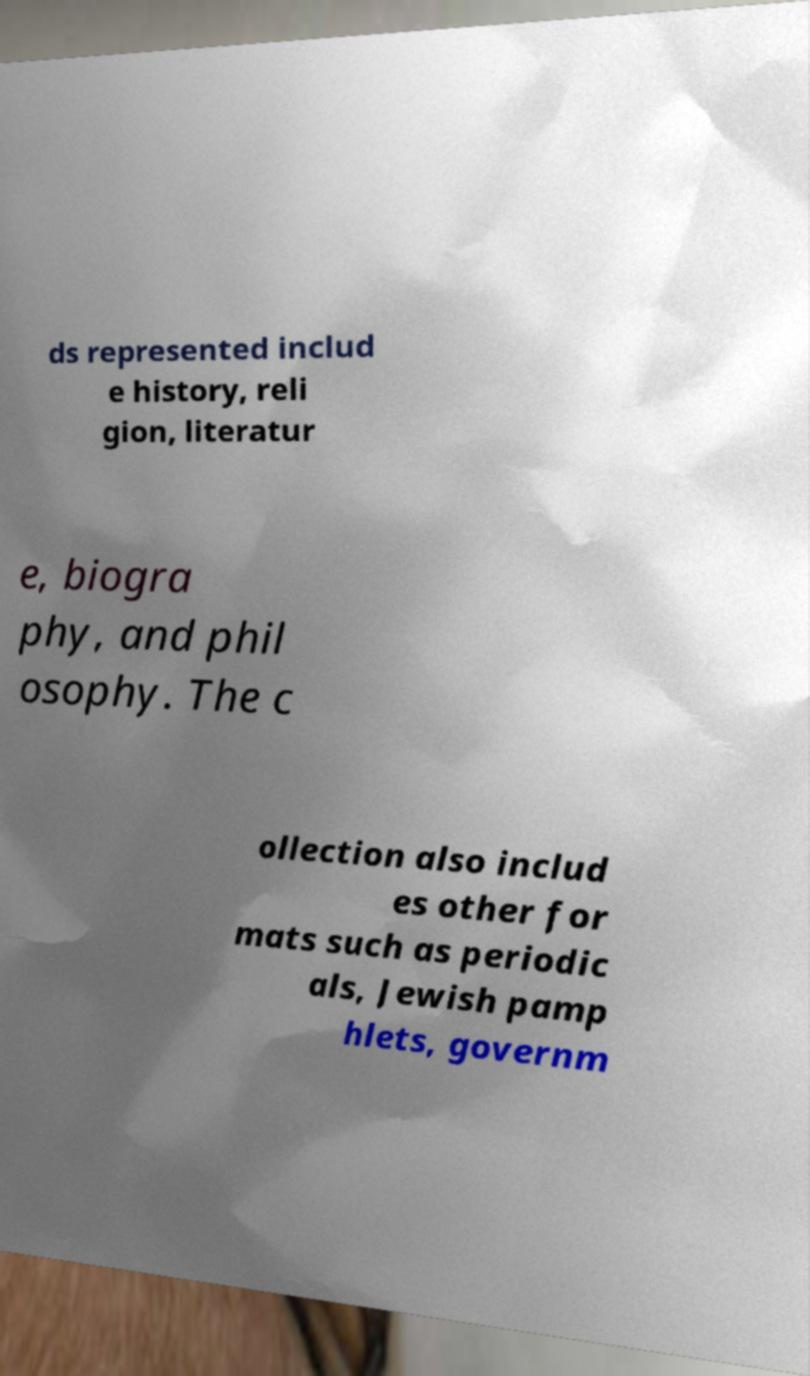What messages or text are displayed in this image? I need them in a readable, typed format. ds represented includ e history, reli gion, literatur e, biogra phy, and phil osophy. The c ollection also includ es other for mats such as periodic als, Jewish pamp hlets, governm 